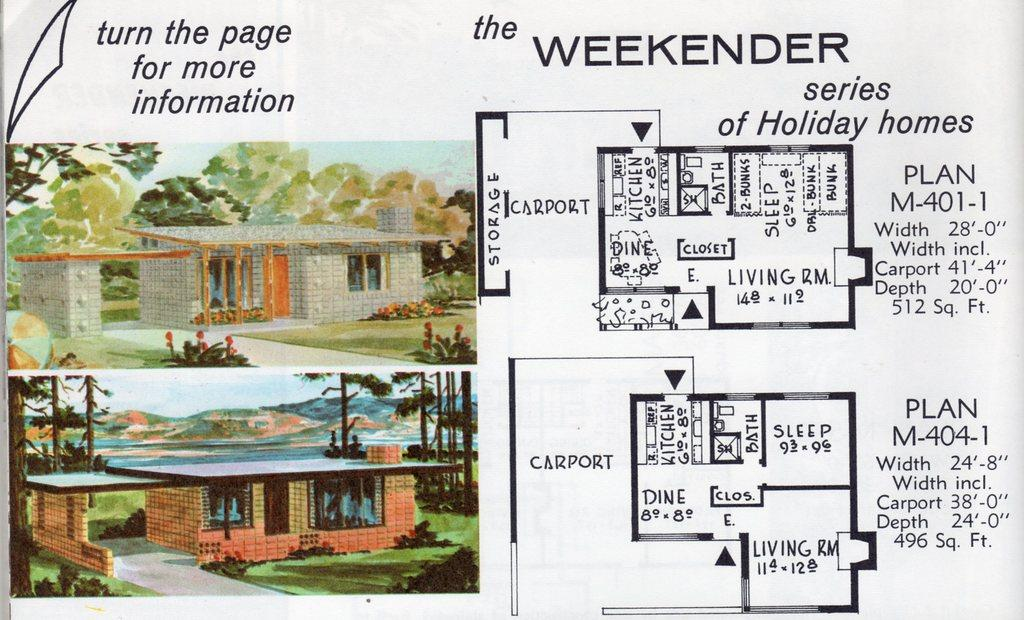<image>
Create a compact narrative representing the image presented. A drawing of a floor plan of a home giving details about the interior measurements and rooms it's a series of Holiday Homes. 